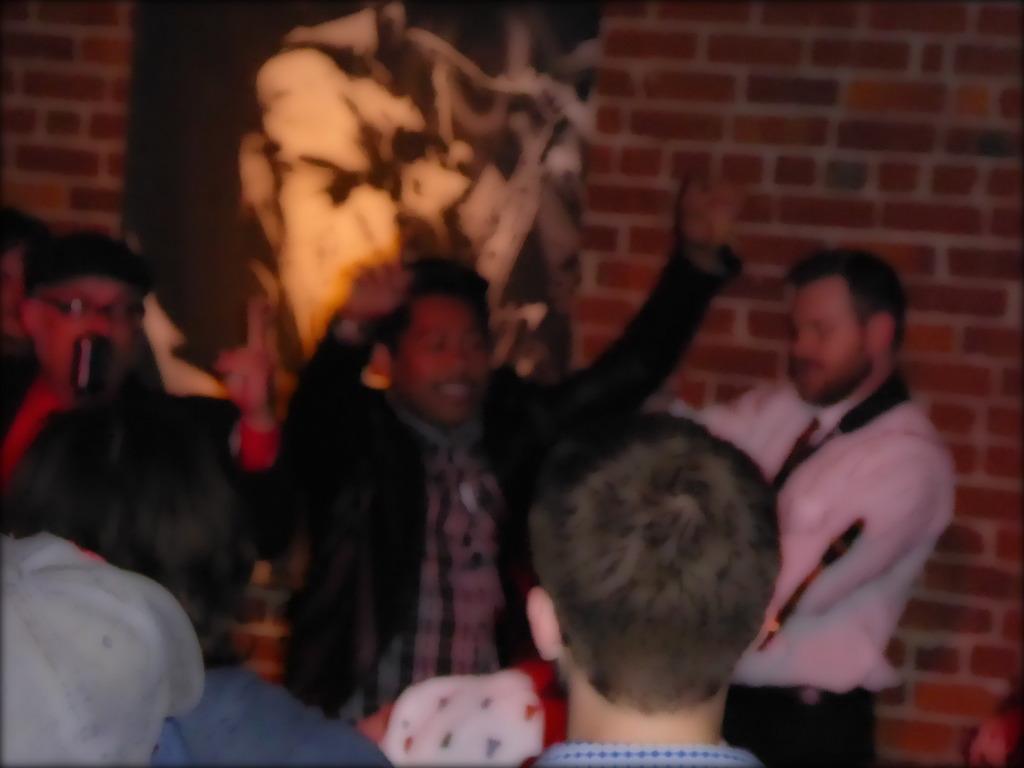Describe this image in one or two sentences. In the foreground, I can see a group of people are dancing on the floor. In the background, I can see a wall and a wall painting. This image taken, maybe in a hall. 